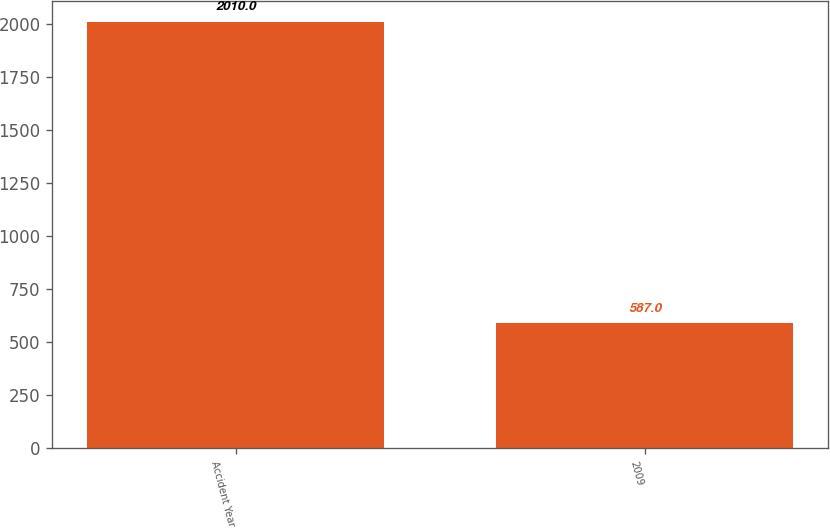<chart> <loc_0><loc_0><loc_500><loc_500><bar_chart><fcel>Accident Year<fcel>2009<nl><fcel>2010<fcel>587<nl></chart> 